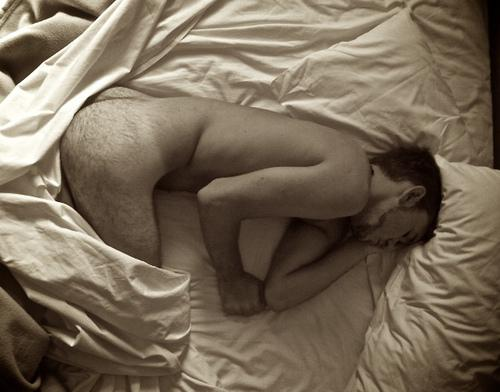Question: what clothes are the man wearing?
Choices:
A. Nothing.
B. Uniform.
C. Coveralls.
D. Jeans and t-shirt.
Answer with the letter. Answer: A Question: what is the man doing?
Choices:
A. Sitting.
B. Sleeping.
C. Laying down.
D. Standing.
Answer with the letter. Answer: B 